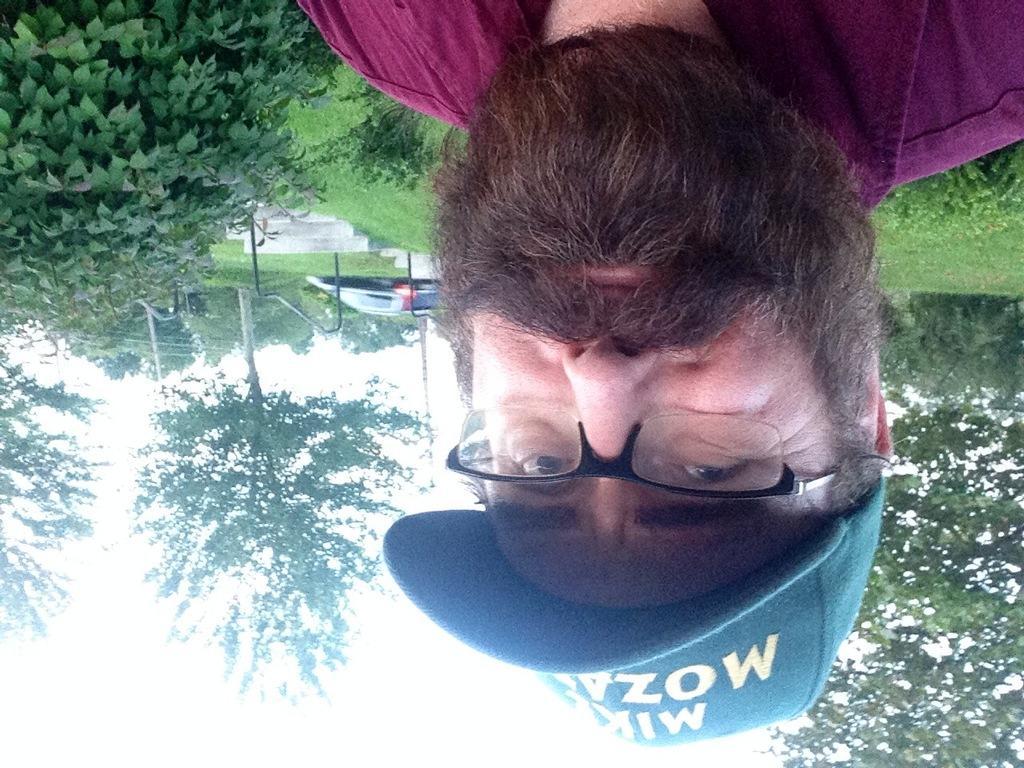Describe this image in one or two sentences. In this picture there is a person having beard is wearing spectacles and a cap and the ground is greenery behind him and there are trees in the background. 